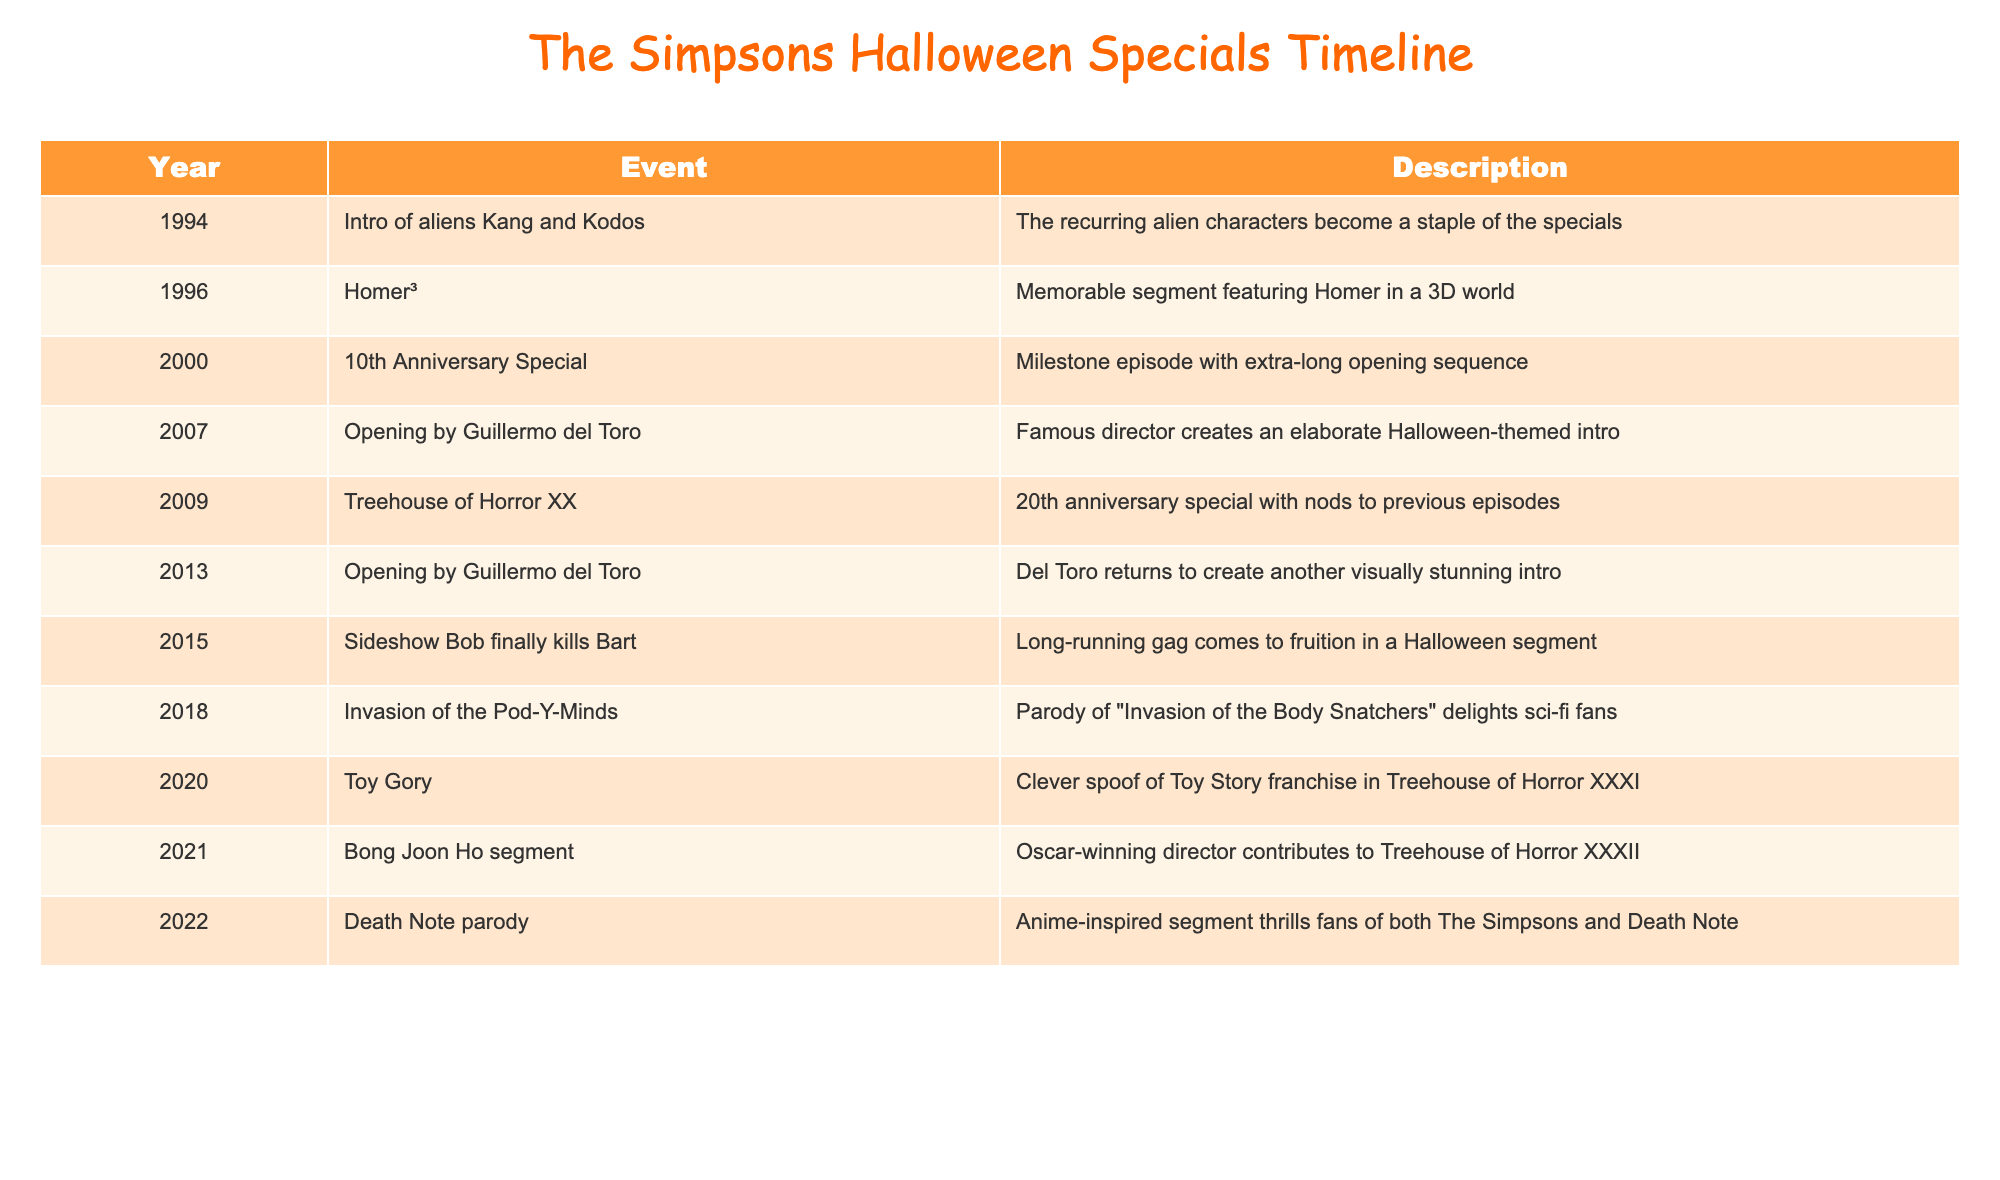What year did Sideshow Bob finally kill Bart? The table lists the significant events in the Halloween specials along with their corresponding years. According to the table, this event occurred in 2015.
Answer: 2015 What event in 1994 introduced recurring alien characters? From the table, it shows that in 1994, the event related to the introduction of the aliens Kang and Kodos took place. This was noted as a staple in the Halloween specials.
Answer: Intro of aliens Kang and Kodos Which year saw an opening segment created by Guillermo del Toro? There are two entries in the table that mention Guillermo del Toro: 2007 and 2013. Both years feature Halloween-themed intros created by him.
Answer: 2007 and 2013 How many unique segments involving Sideshow Bob are mentioned? The table only lists one unique event regarding Sideshow Bob, which is the 2015 segment where he finally kills Bart. Therefore, there is only one segment about Sideshow Bob.
Answer: 1 Which Halloween special has a segment that is a parody of "Invasion of the Body Snatchers"? The table reveals that the "Invasion of the Pod-Y-Minds" segment, which is a parody of "Invasion of the Body Snatchers," occurred in 2018.
Answer: 2018 Is it true that the 2020 Treehouse of Horror was a spoof of a toy franchise? The table specifies that in 2020, the special titled "Toy Gory" is indeed a clever spoof of the Toy Story franchise, making the statement true.
Answer: Yes What is the average year of events featuring Guillermo del Toro? Guillermo del Toro's involvement is noted in 2007 and 2013 in the table. To find the average year, we add both years (2007 + 2013 = 4020) and divide by 2, resulting in an average of 2010.
Answer: 2010 Which Treehouse of Horror special celebrated its 20th anniversary and what was its title? According to the table, Treehouse of Horror XX celebrated its 20th anniversary in 2009, as indicated clearly in the event’s description.
Answer: Treehouse of Horror XX What segment marks the end of a long-running gag in 2015? The table indicates that the 2015 special is noteworthy for the segment where Sideshow Bob finally kills Bart, marking the culmination of a long-running gag.
Answer: Sideshow Bob finally kills Bart 